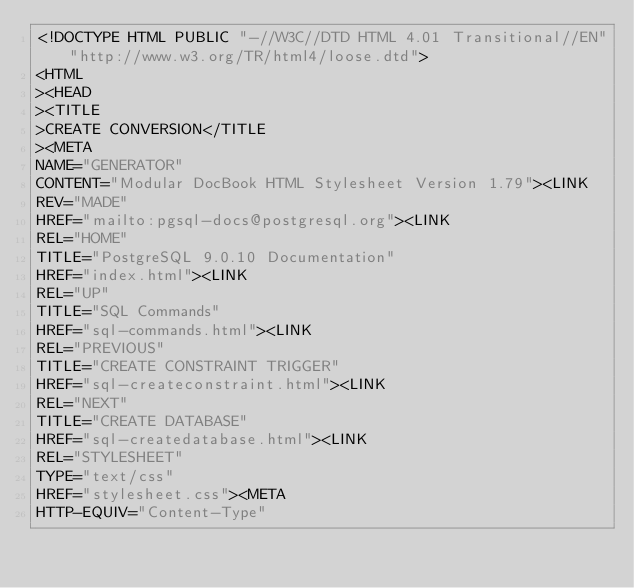Convert code to text. <code><loc_0><loc_0><loc_500><loc_500><_HTML_><!DOCTYPE HTML PUBLIC "-//W3C//DTD HTML 4.01 Transitional//EN""http://www.w3.org/TR/html4/loose.dtd">
<HTML
><HEAD
><TITLE
>CREATE CONVERSION</TITLE
><META
NAME="GENERATOR"
CONTENT="Modular DocBook HTML Stylesheet Version 1.79"><LINK
REV="MADE"
HREF="mailto:pgsql-docs@postgresql.org"><LINK
REL="HOME"
TITLE="PostgreSQL 9.0.10 Documentation"
HREF="index.html"><LINK
REL="UP"
TITLE="SQL Commands"
HREF="sql-commands.html"><LINK
REL="PREVIOUS"
TITLE="CREATE CONSTRAINT TRIGGER"
HREF="sql-createconstraint.html"><LINK
REL="NEXT"
TITLE="CREATE DATABASE"
HREF="sql-createdatabase.html"><LINK
REL="STYLESHEET"
TYPE="text/css"
HREF="stylesheet.css"><META
HTTP-EQUIV="Content-Type"</code> 